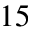Convert formula to latex. <formula><loc_0><loc_0><loc_500><loc_500>^ { 1 5 }</formula> 